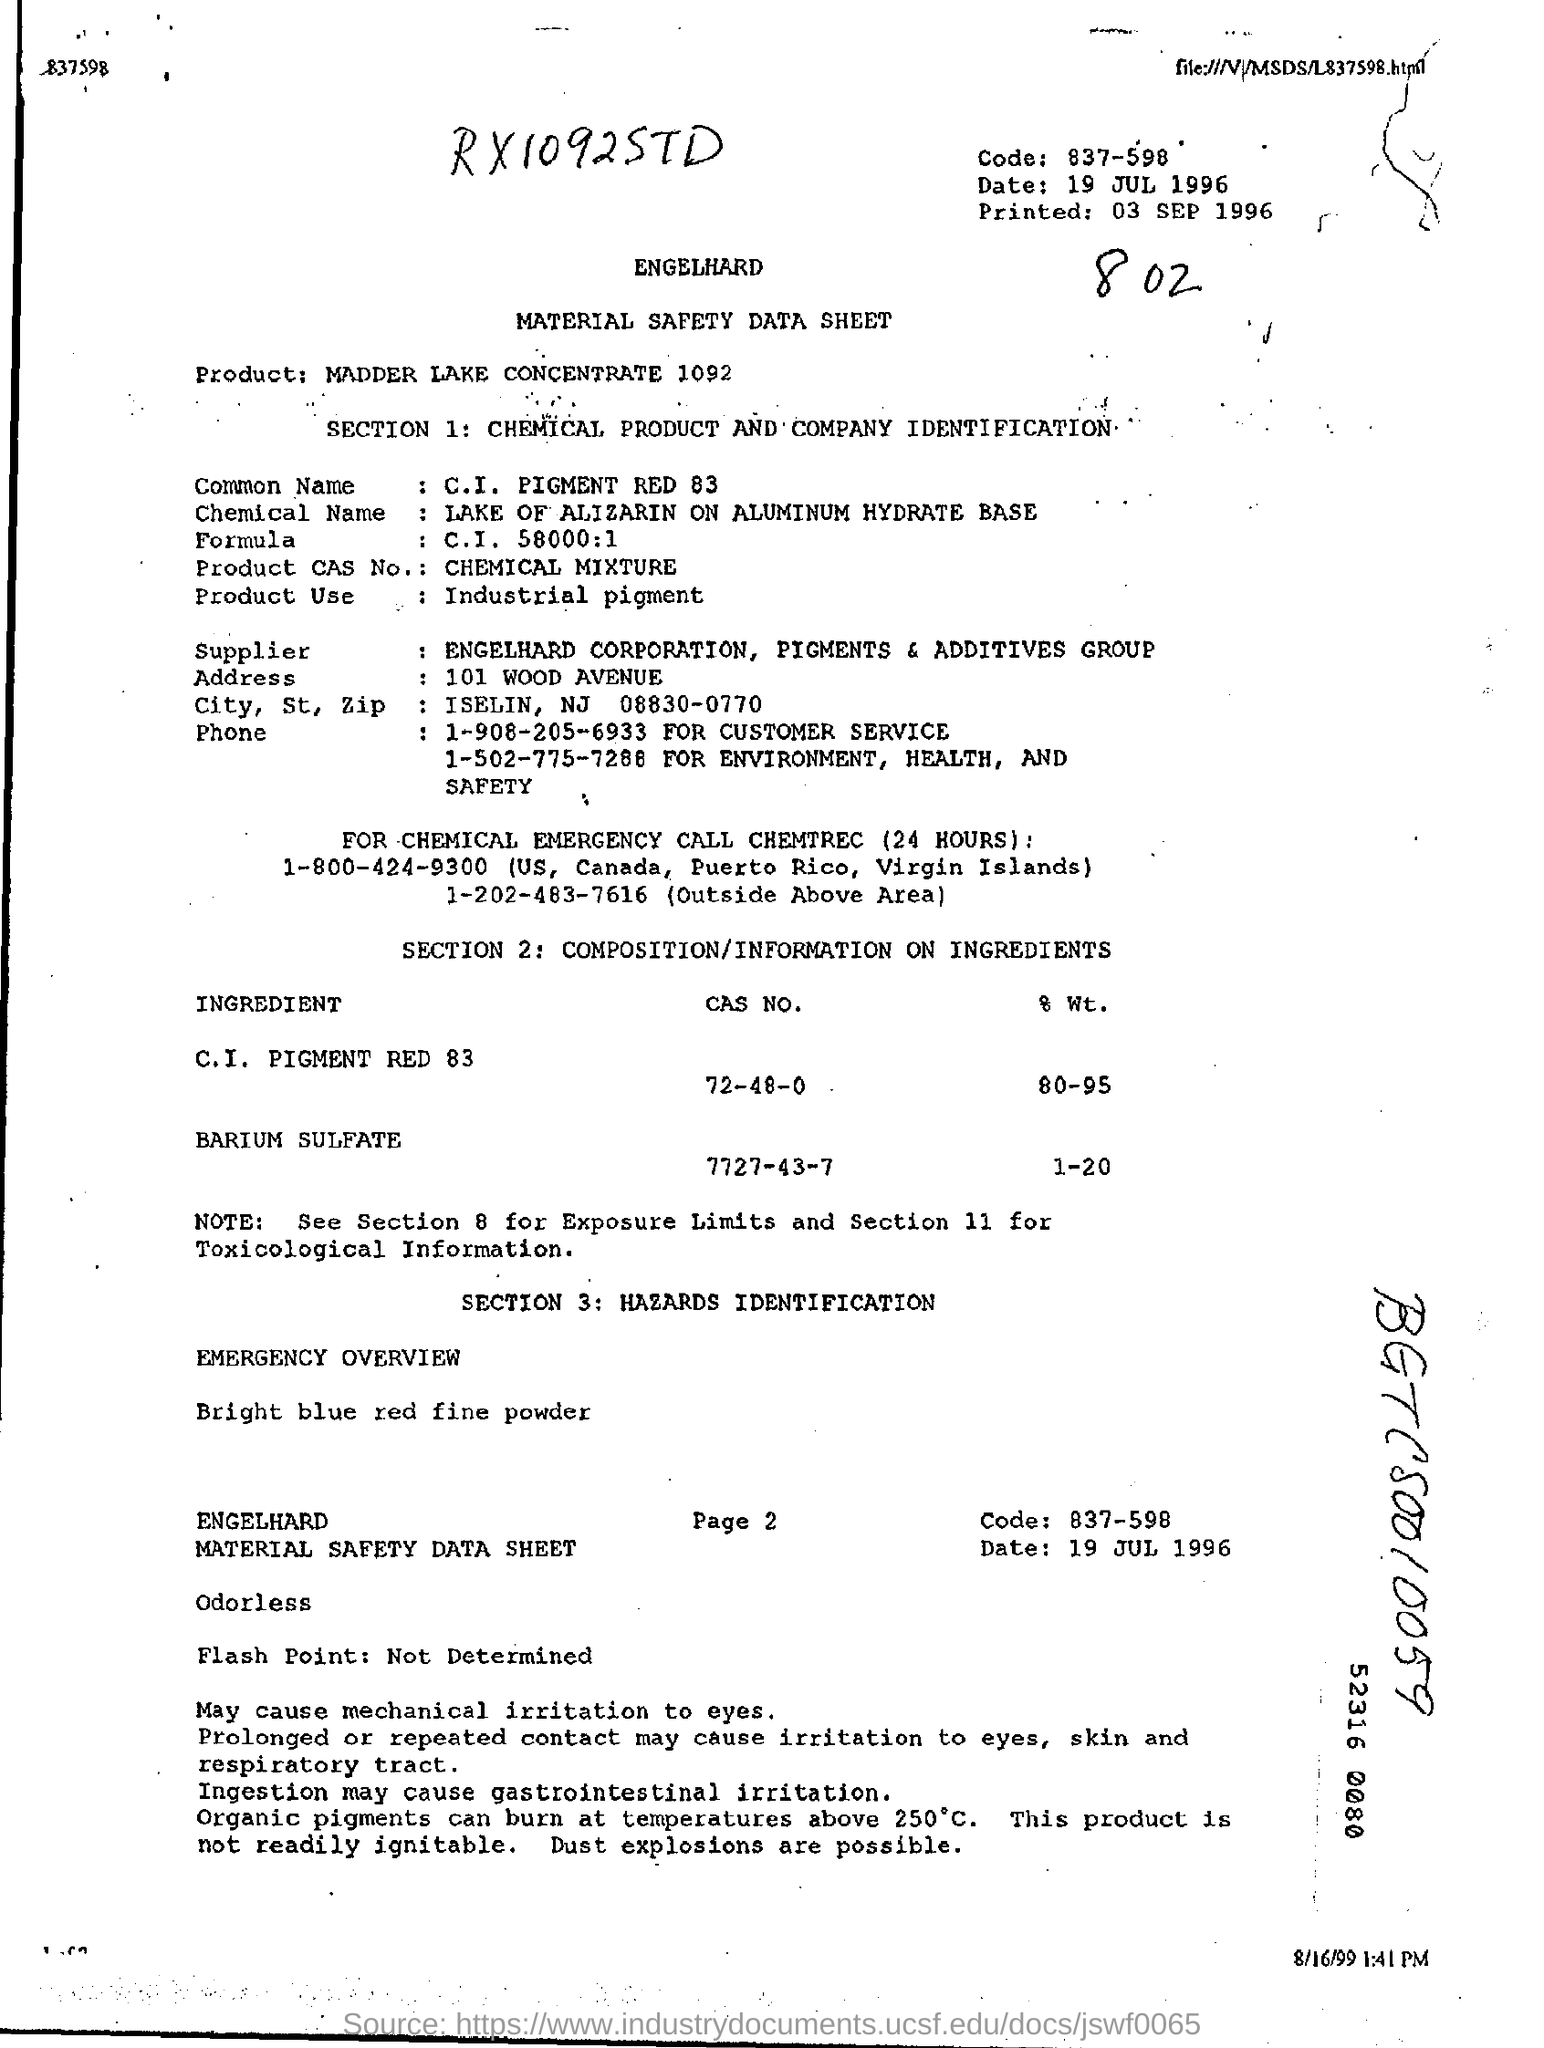When this sheet is printed on?
Your response must be concise. 03 SEP 1996. What is mentioned as Product?
Make the answer very short. Madder Lake Concentrate 1092. What is printed as Flash point?
Provide a short and direct response. Not determined. 